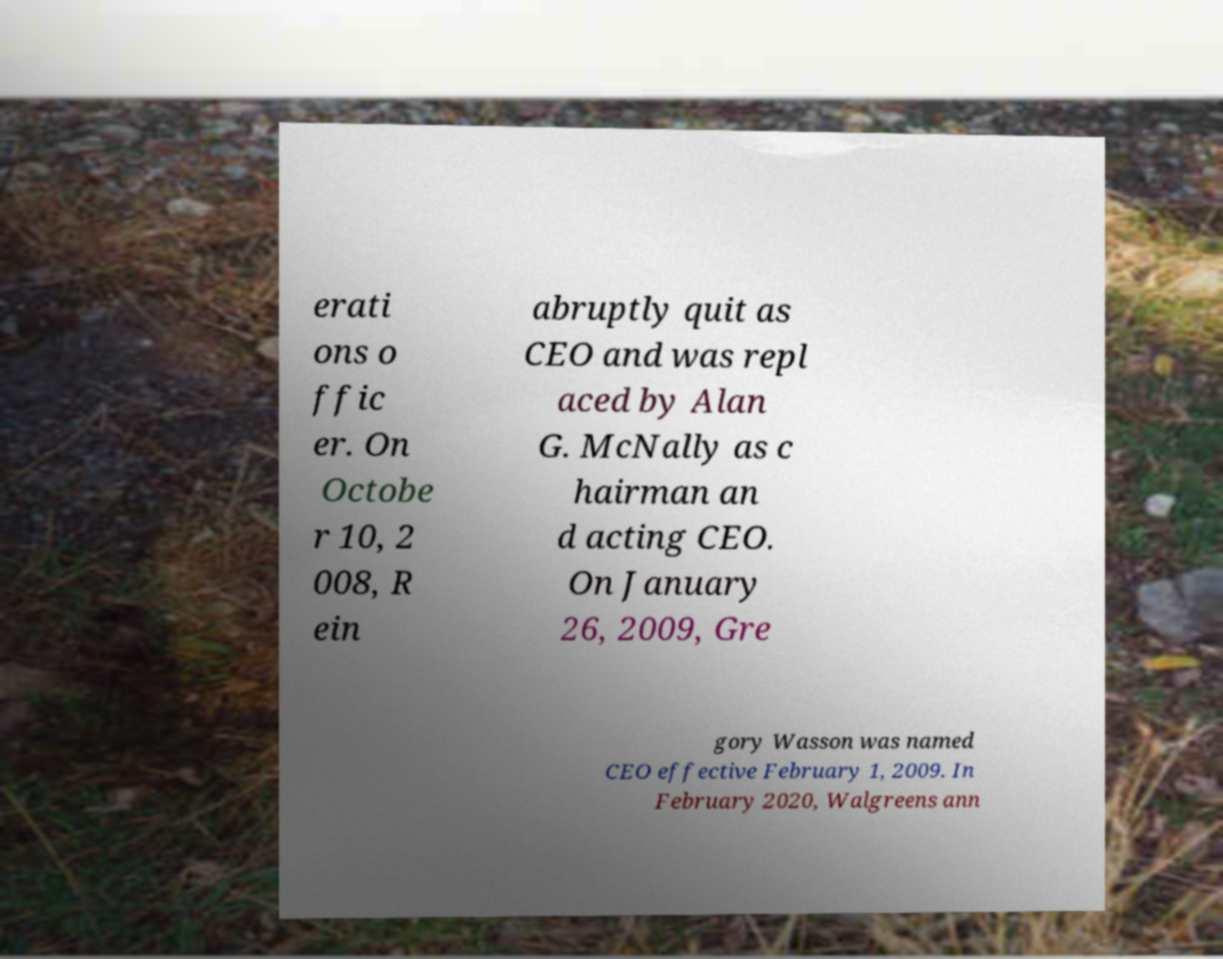What messages or text are displayed in this image? I need them in a readable, typed format. erati ons o ffic er. On Octobe r 10, 2 008, R ein abruptly quit as CEO and was repl aced by Alan G. McNally as c hairman an d acting CEO. On January 26, 2009, Gre gory Wasson was named CEO effective February 1, 2009. In February 2020, Walgreens ann 